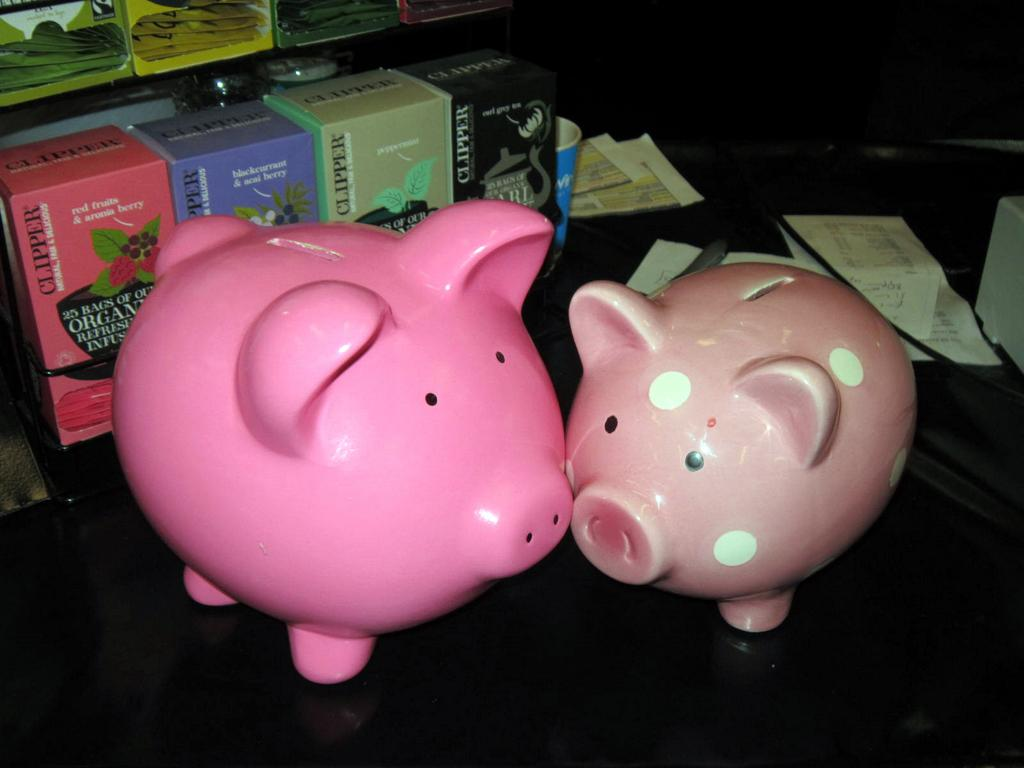How many piggy banks can be seen in the image? There are two piggy banks in the image. What else is present in the image besides the piggy banks? There is a group of boxes and papers placed on a surface in the image. Can you describe the background of the image? In the background, there are boxes containing packets on a rack. Is there a dog playing with the piggy banks in the image? No, there is no dog present in the image. Can you tell me the age of the grandfather in the image? There is no grandfather present in the image. 